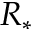Convert formula to latex. <formula><loc_0><loc_0><loc_500><loc_500>R _ { * }</formula> 